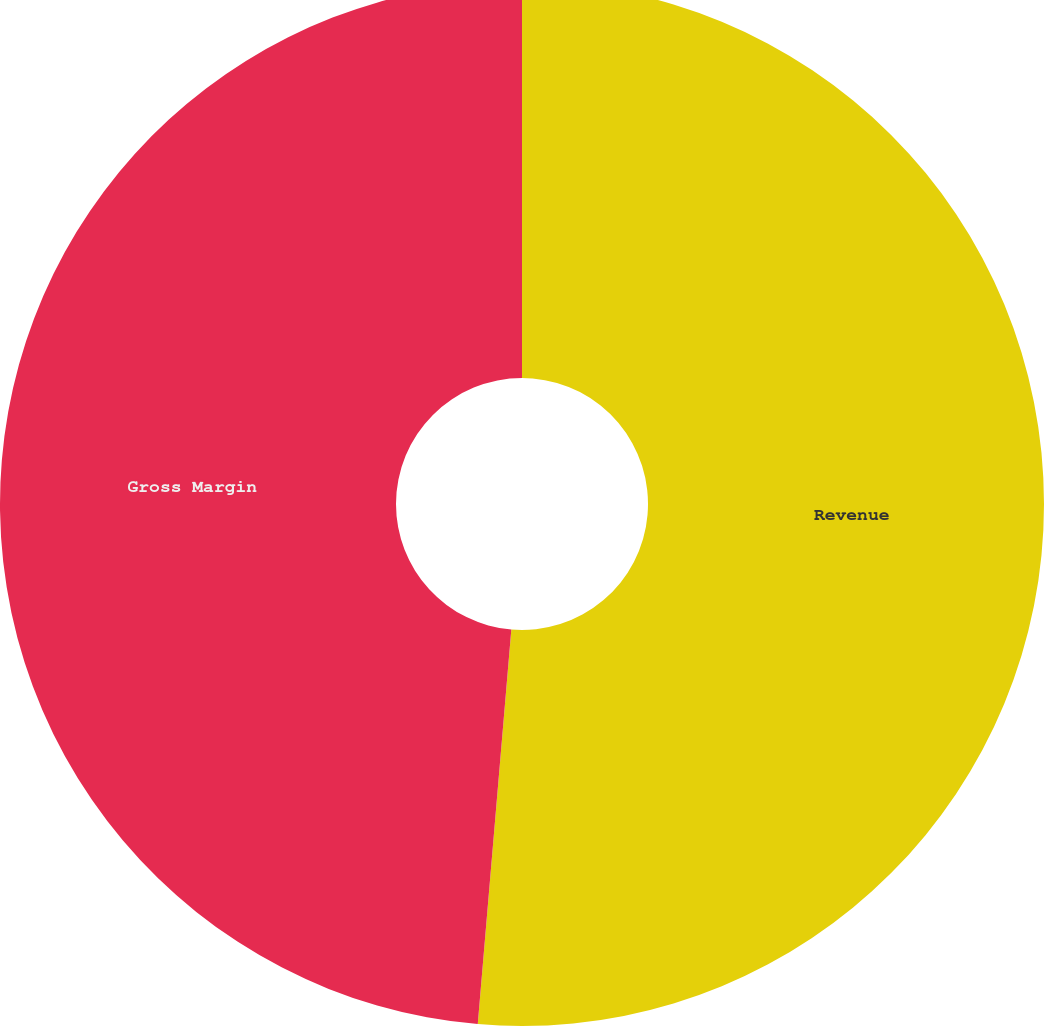<chart> <loc_0><loc_0><loc_500><loc_500><pie_chart><fcel>Revenue<fcel>Gross Margin<nl><fcel>51.35%<fcel>48.65%<nl></chart> 